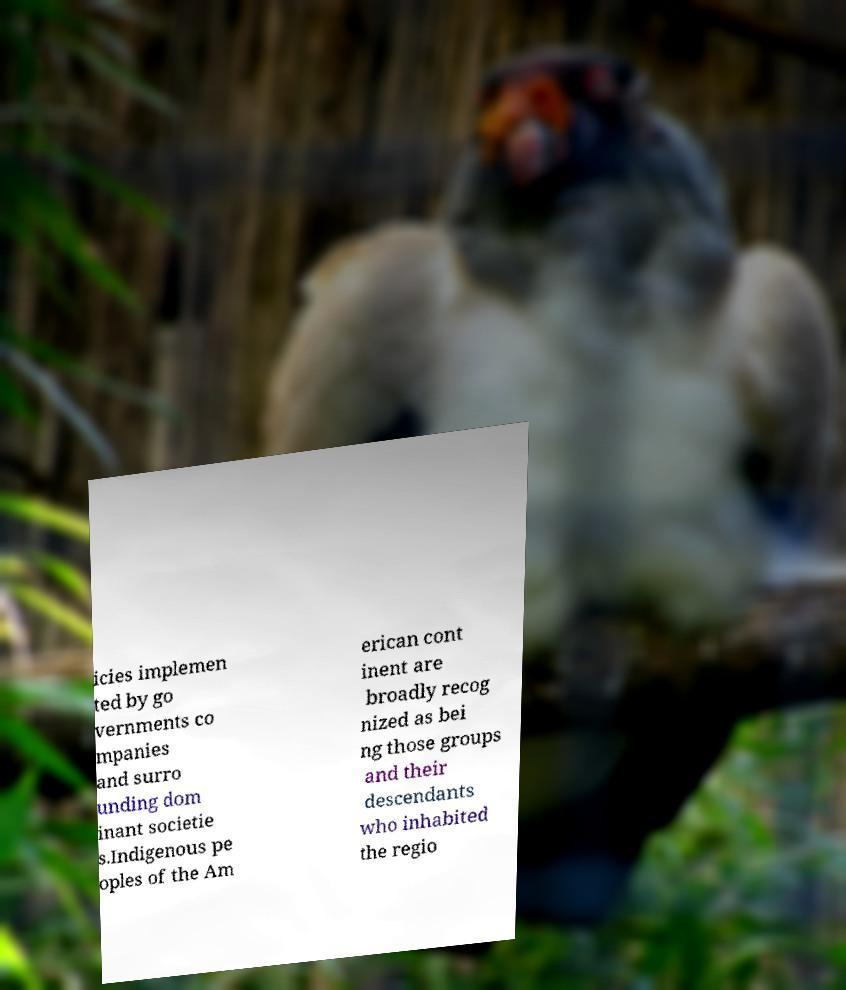I need the written content from this picture converted into text. Can you do that? icies implemen ted by go vernments co mpanies and surro unding dom inant societie s.Indigenous pe oples of the Am erican cont inent are broadly recog nized as bei ng those groups and their descendants who inhabited the regio 